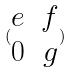Convert formula to latex. <formula><loc_0><loc_0><loc_500><loc_500>( \begin{matrix} e & f \\ 0 & g \end{matrix} )</formula> 